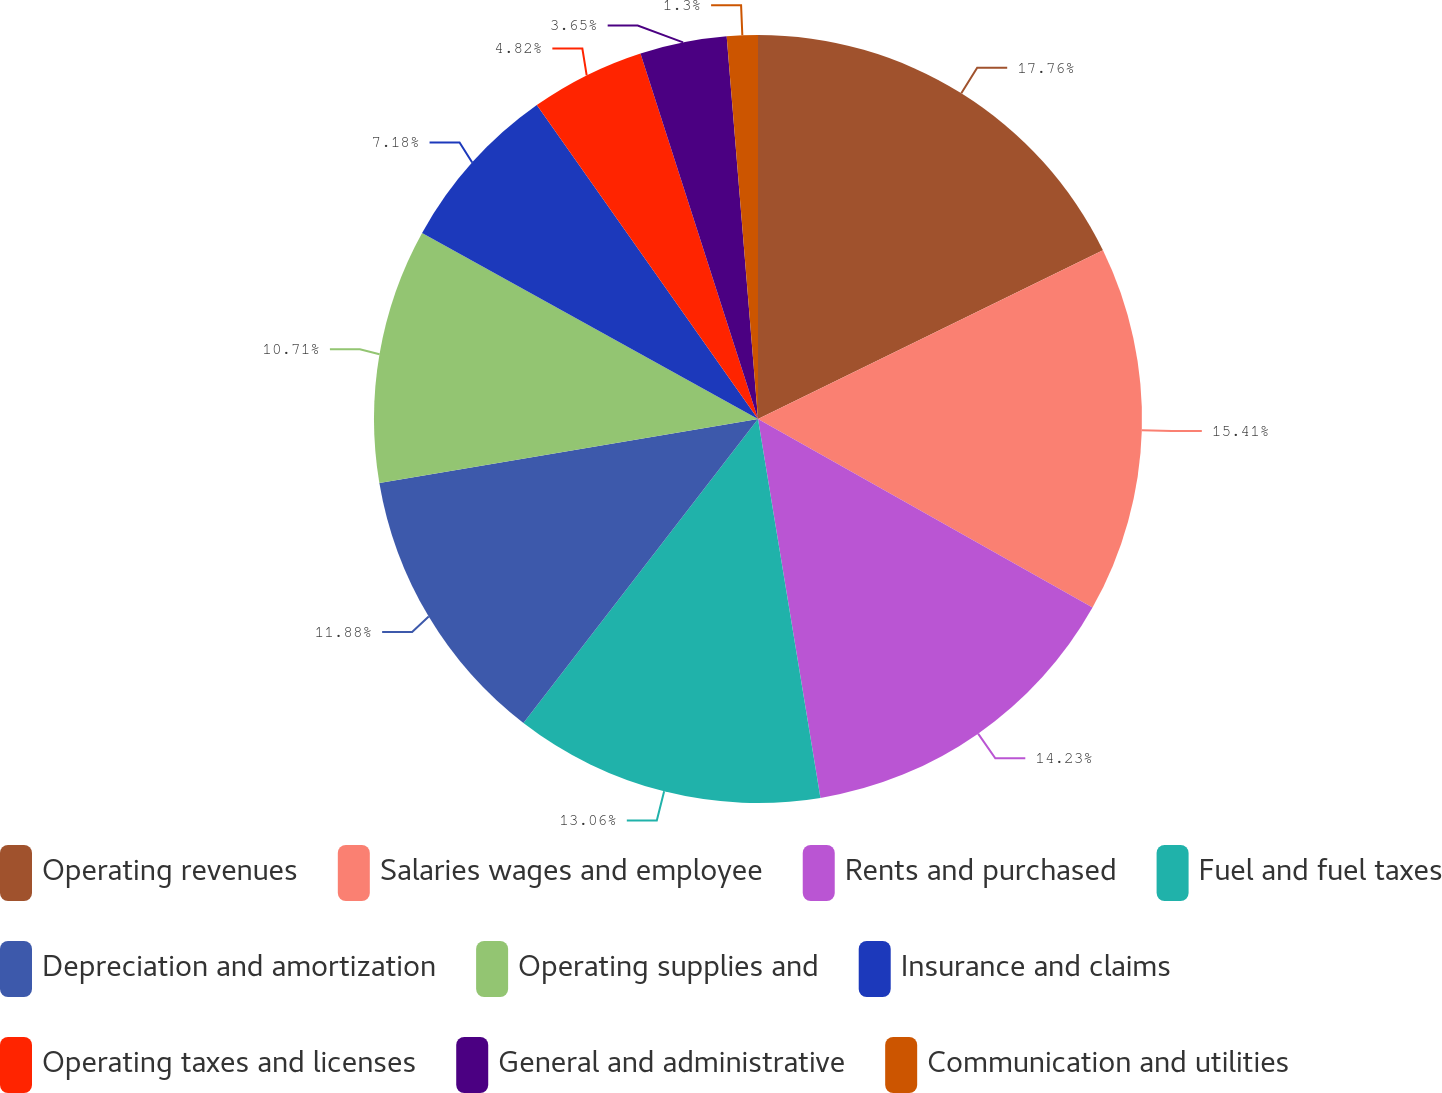<chart> <loc_0><loc_0><loc_500><loc_500><pie_chart><fcel>Operating revenues<fcel>Salaries wages and employee<fcel>Rents and purchased<fcel>Fuel and fuel taxes<fcel>Depreciation and amortization<fcel>Operating supplies and<fcel>Insurance and claims<fcel>Operating taxes and licenses<fcel>General and administrative<fcel>Communication and utilities<nl><fcel>17.76%<fcel>15.41%<fcel>14.23%<fcel>13.06%<fcel>11.88%<fcel>10.71%<fcel>7.18%<fcel>4.82%<fcel>3.65%<fcel>1.3%<nl></chart> 